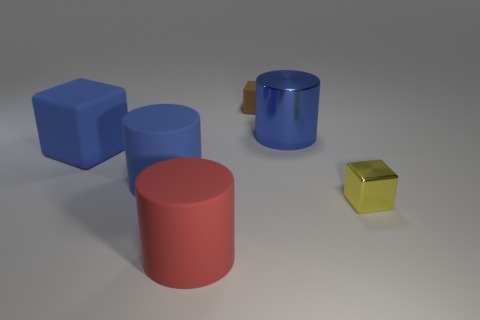Is the color of the metallic block the same as the large shiny cylinder?
Provide a short and direct response. No. What is the color of the other thing that is the same material as the tiny yellow object?
Keep it short and to the point. Blue. There is a cylinder that is the same color as the big metal object; what is its material?
Ensure brevity in your answer.  Rubber. What color is the cylinder that is to the right of the rubber thing that is in front of the blue cylinder left of the blue metal object?
Provide a succinct answer. Blue. Are there any other things that are the same size as the yellow metallic block?
Provide a short and direct response. Yes. There is a large cube; is it the same color as the cylinder that is left of the big red thing?
Offer a very short reply. Yes. The tiny rubber object is what color?
Provide a short and direct response. Brown. The rubber object that is in front of the cube right of the blue object right of the big red matte thing is what shape?
Provide a short and direct response. Cylinder. How many other things are the same color as the tiny metal cube?
Offer a very short reply. 0. Is the number of big blue blocks in front of the small metallic cube greater than the number of small brown cubes in front of the large red object?
Your response must be concise. No. 